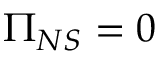Convert formula to latex. <formula><loc_0><loc_0><loc_500><loc_500>\Pi _ { N S } = 0</formula> 